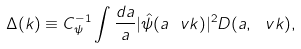Convert formula to latex. <formula><loc_0><loc_0><loc_500><loc_500>\Delta ( k ) \equiv C _ { \psi } ^ { - 1 } \int \frac { d a } { a } | \hat { \psi } ( a \ v k ) | ^ { 2 } D ( a , \ v k ) ,</formula> 